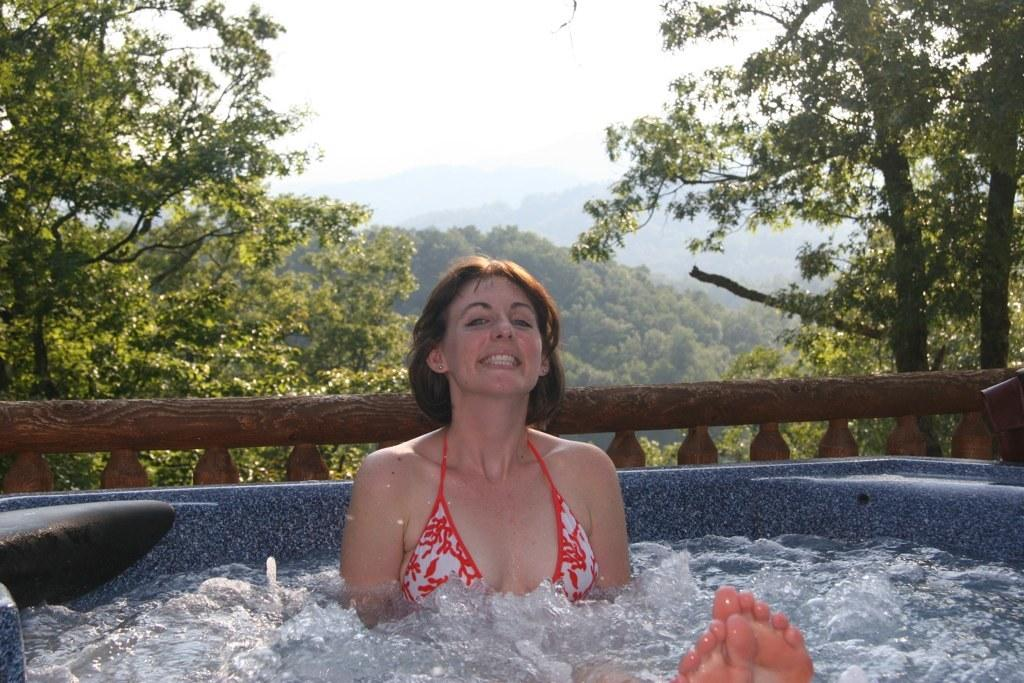Who is present in the image? There is a woman in the image. What is the woman's expression? The woman is smiling. What can be seen in the foreground of the image? There is water visible in the image. What architectural feature is present in the image? There is a fence in the image. What can be seen in the background of the image? There are trees and the sky visible in the background of the image. What decision did the woman make regarding the care of the rule in the image? There is no rule present in the image, and therefore no decision regarding its care can be made. 